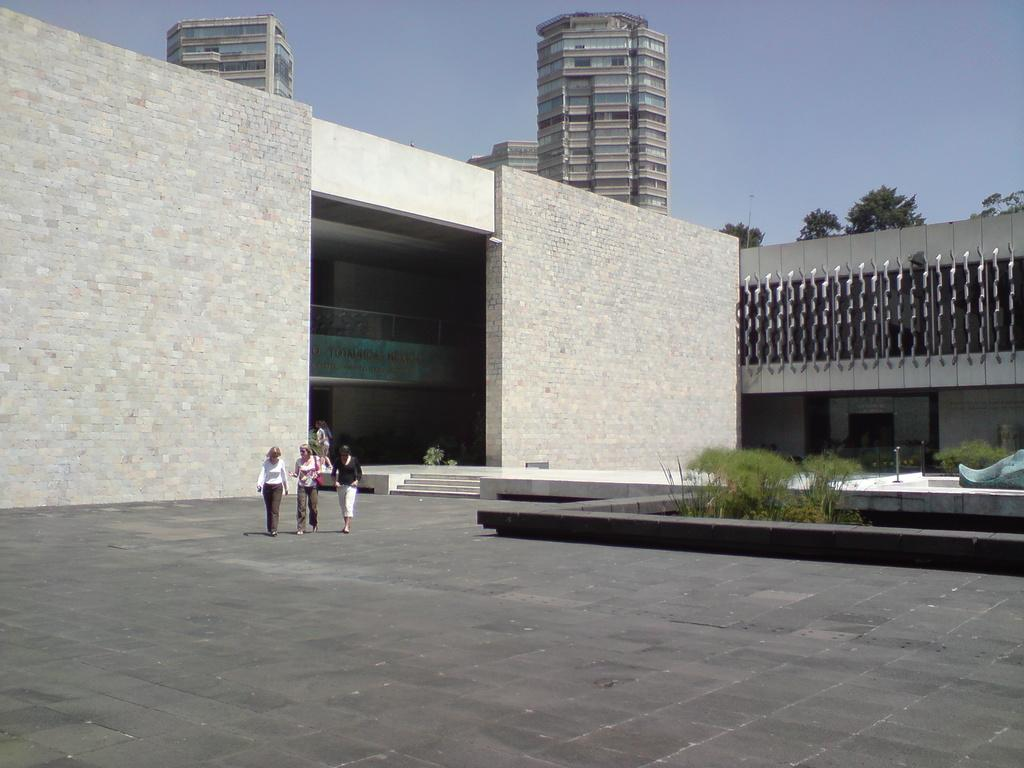What are the people in the image doing? There are people walking in the image. What else can be seen in the image besides people? There are plants, a sculpture, and steps visible in the image. What can be seen in the background of the image? In the background, there are people, a building, trees, and the sky. How much sugar is in the tent in the image? There is no tent present in the image, and therefore no sugar can be associated with it. 